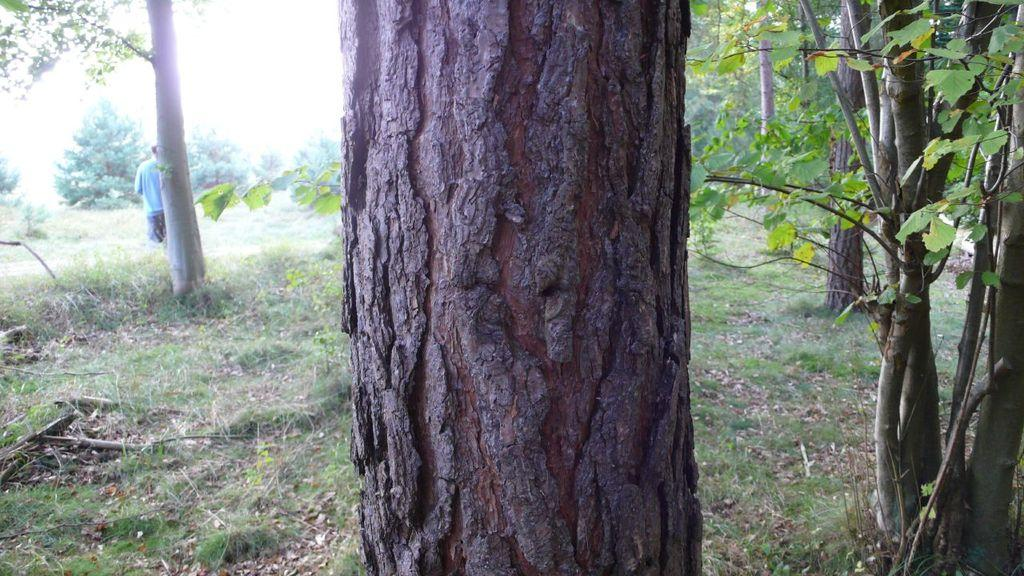What type of vegetation can be seen in the image? There are tree trunks and trees in the image. What type of ground cover is present in the image? There is grass in the image. Can you describe the person in the image? There is a person standing on the left side of the image. What type of addition problem is the person solving in the image? There is no indication in the image that the person is solving an addition problem, as the person is simply standing on the left side of the image. What kind of breakfast is the person eating in the image? There is no indication in the image that the person is eating breakfast, as the person is simply standing on the left side of the image. 